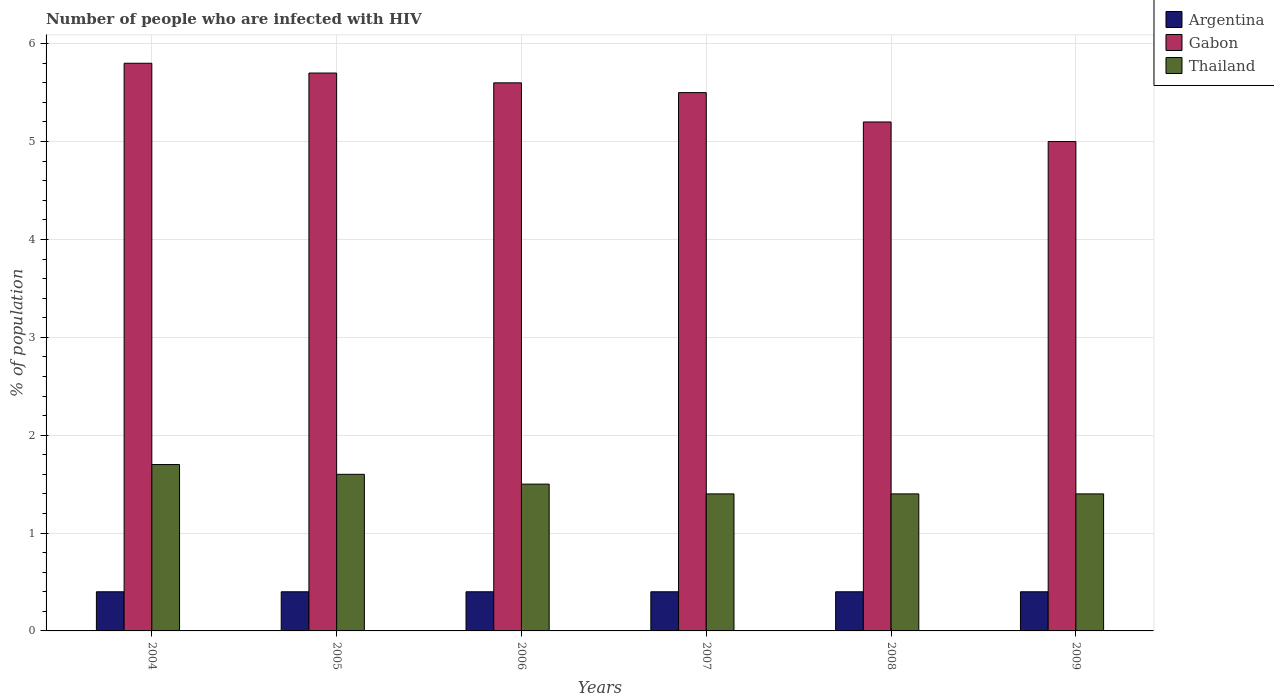How many different coloured bars are there?
Your answer should be very brief. 3. How many groups of bars are there?
Ensure brevity in your answer.  6. How many bars are there on the 6th tick from the right?
Provide a succinct answer. 3. What is the label of the 6th group of bars from the left?
Offer a very short reply. 2009. In how many cases, is the number of bars for a given year not equal to the number of legend labels?
Offer a very short reply. 0. Across all years, what is the maximum percentage of HIV infected population in in Thailand?
Your response must be concise. 1.7. What is the difference between the percentage of HIV infected population in in Thailand in 2005 and that in 2006?
Give a very brief answer. 0.1. What is the difference between the percentage of HIV infected population in in Thailand in 2008 and the percentage of HIV infected population in in Gabon in 2005?
Give a very brief answer. -4.3. What is the average percentage of HIV infected population in in Argentina per year?
Your answer should be compact. 0.4. In how many years, is the percentage of HIV infected population in in Argentina greater than 3.4 %?
Keep it short and to the point. 0. What is the ratio of the percentage of HIV infected population in in Gabon in 2004 to that in 2005?
Your answer should be compact. 1.02. Is the difference between the percentage of HIV infected population in in Argentina in 2007 and 2009 greater than the difference between the percentage of HIV infected population in in Gabon in 2007 and 2009?
Provide a short and direct response. No. What is the difference between the highest and the lowest percentage of HIV infected population in in Gabon?
Make the answer very short. 0.8. In how many years, is the percentage of HIV infected population in in Gabon greater than the average percentage of HIV infected population in in Gabon taken over all years?
Keep it short and to the point. 4. Is the sum of the percentage of HIV infected population in in Gabon in 2006 and 2009 greater than the maximum percentage of HIV infected population in in Thailand across all years?
Offer a very short reply. Yes. What does the 2nd bar from the left in 2007 represents?
Make the answer very short. Gabon. What does the 3rd bar from the right in 2007 represents?
Your answer should be compact. Argentina. How many bars are there?
Provide a short and direct response. 18. How many years are there in the graph?
Provide a short and direct response. 6. What is the difference between two consecutive major ticks on the Y-axis?
Keep it short and to the point. 1. Does the graph contain any zero values?
Keep it short and to the point. No. Where does the legend appear in the graph?
Give a very brief answer. Top right. What is the title of the graph?
Make the answer very short. Number of people who are infected with HIV. Does "Korea (Democratic)" appear as one of the legend labels in the graph?
Your response must be concise. No. What is the label or title of the X-axis?
Offer a terse response. Years. What is the label or title of the Y-axis?
Provide a succinct answer. % of population. What is the % of population in Thailand in 2004?
Provide a succinct answer. 1.7. What is the % of population of Thailand in 2005?
Your answer should be very brief. 1.6. What is the % of population in Argentina in 2006?
Your answer should be compact. 0.4. What is the % of population of Gabon in 2006?
Your response must be concise. 5.6. What is the % of population in Argentina in 2007?
Provide a short and direct response. 0.4. What is the % of population in Gabon in 2007?
Provide a short and direct response. 5.5. What is the % of population of Gabon in 2008?
Provide a succinct answer. 5.2. What is the % of population of Thailand in 2008?
Your answer should be very brief. 1.4. What is the % of population of Argentina in 2009?
Ensure brevity in your answer.  0.4. What is the % of population in Gabon in 2009?
Your answer should be very brief. 5. What is the % of population of Thailand in 2009?
Your response must be concise. 1.4. Across all years, what is the maximum % of population in Argentina?
Provide a succinct answer. 0.4. Across all years, what is the maximum % of population in Gabon?
Your answer should be compact. 5.8. Across all years, what is the minimum % of population in Argentina?
Your response must be concise. 0.4. Across all years, what is the minimum % of population in Thailand?
Provide a short and direct response. 1.4. What is the total % of population in Argentina in the graph?
Offer a terse response. 2.4. What is the total % of population of Gabon in the graph?
Your answer should be very brief. 32.8. What is the difference between the % of population in Gabon in 2004 and that in 2005?
Your answer should be compact. 0.1. What is the difference between the % of population of Thailand in 2004 and that in 2005?
Keep it short and to the point. 0.1. What is the difference between the % of population in Argentina in 2004 and that in 2006?
Give a very brief answer. 0. What is the difference between the % of population in Argentina in 2004 and that in 2007?
Your answer should be compact. 0. What is the difference between the % of population in Thailand in 2004 and that in 2007?
Your answer should be compact. 0.3. What is the difference between the % of population of Gabon in 2004 and that in 2008?
Provide a succinct answer. 0.6. What is the difference between the % of population in Thailand in 2004 and that in 2008?
Your answer should be very brief. 0.3. What is the difference between the % of population in Thailand in 2004 and that in 2009?
Make the answer very short. 0.3. What is the difference between the % of population of Argentina in 2005 and that in 2006?
Provide a succinct answer. 0. What is the difference between the % of population in Thailand in 2005 and that in 2007?
Offer a very short reply. 0.2. What is the difference between the % of population of Gabon in 2005 and that in 2009?
Make the answer very short. 0.7. What is the difference between the % of population of Thailand in 2006 and that in 2007?
Provide a short and direct response. 0.1. What is the difference between the % of population of Thailand in 2006 and that in 2008?
Ensure brevity in your answer.  0.1. What is the difference between the % of population in Gabon in 2006 and that in 2009?
Give a very brief answer. 0.6. What is the difference between the % of population in Thailand in 2006 and that in 2009?
Offer a very short reply. 0.1. What is the difference between the % of population of Gabon in 2007 and that in 2008?
Keep it short and to the point. 0.3. What is the difference between the % of population of Gabon in 2008 and that in 2009?
Offer a terse response. 0.2. What is the difference between the % of population of Argentina in 2004 and the % of population of Gabon in 2005?
Offer a very short reply. -5.3. What is the difference between the % of population in Gabon in 2004 and the % of population in Thailand in 2005?
Offer a terse response. 4.2. What is the difference between the % of population in Argentina in 2004 and the % of population in Thailand in 2006?
Keep it short and to the point. -1.1. What is the difference between the % of population of Gabon in 2004 and the % of population of Thailand in 2007?
Offer a very short reply. 4.4. What is the difference between the % of population in Gabon in 2004 and the % of population in Thailand in 2008?
Offer a terse response. 4.4. What is the difference between the % of population in Gabon in 2004 and the % of population in Thailand in 2009?
Give a very brief answer. 4.4. What is the difference between the % of population of Argentina in 2005 and the % of population of Gabon in 2006?
Offer a very short reply. -5.2. What is the difference between the % of population in Argentina in 2005 and the % of population in Thailand in 2007?
Give a very brief answer. -1. What is the difference between the % of population in Argentina in 2005 and the % of population in Thailand in 2009?
Ensure brevity in your answer.  -1. What is the difference between the % of population of Argentina in 2006 and the % of population of Thailand in 2007?
Offer a very short reply. -1. What is the difference between the % of population of Argentina in 2006 and the % of population of Thailand in 2008?
Give a very brief answer. -1. What is the difference between the % of population of Gabon in 2006 and the % of population of Thailand in 2008?
Offer a terse response. 4.2. What is the difference between the % of population of Argentina in 2006 and the % of population of Gabon in 2009?
Keep it short and to the point. -4.6. What is the difference between the % of population in Argentina in 2006 and the % of population in Thailand in 2009?
Your answer should be compact. -1. What is the difference between the % of population in Argentina in 2007 and the % of population in Gabon in 2008?
Make the answer very short. -4.8. What is the difference between the % of population in Argentina in 2007 and the % of population in Gabon in 2009?
Your answer should be very brief. -4.6. What is the difference between the % of population of Argentina in 2007 and the % of population of Thailand in 2009?
Make the answer very short. -1. What is the difference between the % of population of Gabon in 2007 and the % of population of Thailand in 2009?
Make the answer very short. 4.1. What is the difference between the % of population of Argentina in 2008 and the % of population of Gabon in 2009?
Your answer should be very brief. -4.6. What is the difference between the % of population of Gabon in 2008 and the % of population of Thailand in 2009?
Offer a very short reply. 3.8. What is the average % of population of Gabon per year?
Your answer should be very brief. 5.47. What is the average % of population of Thailand per year?
Keep it short and to the point. 1.5. In the year 2004, what is the difference between the % of population in Gabon and % of population in Thailand?
Keep it short and to the point. 4.1. In the year 2006, what is the difference between the % of population of Gabon and % of population of Thailand?
Ensure brevity in your answer.  4.1. In the year 2007, what is the difference between the % of population in Argentina and % of population in Gabon?
Your answer should be compact. -5.1. In the year 2008, what is the difference between the % of population of Argentina and % of population of Thailand?
Provide a short and direct response. -1. In the year 2009, what is the difference between the % of population of Argentina and % of population of Gabon?
Your answer should be very brief. -4.6. In the year 2009, what is the difference between the % of population in Gabon and % of population in Thailand?
Provide a short and direct response. 3.6. What is the ratio of the % of population of Gabon in 2004 to that in 2005?
Your answer should be compact. 1.02. What is the ratio of the % of population of Gabon in 2004 to that in 2006?
Offer a terse response. 1.04. What is the ratio of the % of population of Thailand in 2004 to that in 2006?
Your answer should be compact. 1.13. What is the ratio of the % of population in Gabon in 2004 to that in 2007?
Your answer should be compact. 1.05. What is the ratio of the % of population of Thailand in 2004 to that in 2007?
Your answer should be compact. 1.21. What is the ratio of the % of population in Argentina in 2004 to that in 2008?
Offer a very short reply. 1. What is the ratio of the % of population in Gabon in 2004 to that in 2008?
Offer a very short reply. 1.12. What is the ratio of the % of population in Thailand in 2004 to that in 2008?
Offer a terse response. 1.21. What is the ratio of the % of population of Gabon in 2004 to that in 2009?
Provide a succinct answer. 1.16. What is the ratio of the % of population in Thailand in 2004 to that in 2009?
Provide a succinct answer. 1.21. What is the ratio of the % of population of Gabon in 2005 to that in 2006?
Offer a very short reply. 1.02. What is the ratio of the % of population in Thailand in 2005 to that in 2006?
Your response must be concise. 1.07. What is the ratio of the % of population in Argentina in 2005 to that in 2007?
Provide a short and direct response. 1. What is the ratio of the % of population of Gabon in 2005 to that in 2007?
Provide a succinct answer. 1.04. What is the ratio of the % of population in Thailand in 2005 to that in 2007?
Provide a succinct answer. 1.14. What is the ratio of the % of population in Argentina in 2005 to that in 2008?
Make the answer very short. 1. What is the ratio of the % of population of Gabon in 2005 to that in 2008?
Your response must be concise. 1.1. What is the ratio of the % of population in Thailand in 2005 to that in 2008?
Give a very brief answer. 1.14. What is the ratio of the % of population of Argentina in 2005 to that in 2009?
Give a very brief answer. 1. What is the ratio of the % of population in Gabon in 2005 to that in 2009?
Offer a terse response. 1.14. What is the ratio of the % of population of Gabon in 2006 to that in 2007?
Make the answer very short. 1.02. What is the ratio of the % of population in Thailand in 2006 to that in 2007?
Your response must be concise. 1.07. What is the ratio of the % of population of Argentina in 2006 to that in 2008?
Give a very brief answer. 1. What is the ratio of the % of population in Thailand in 2006 to that in 2008?
Provide a short and direct response. 1.07. What is the ratio of the % of population in Argentina in 2006 to that in 2009?
Provide a short and direct response. 1. What is the ratio of the % of population of Gabon in 2006 to that in 2009?
Make the answer very short. 1.12. What is the ratio of the % of population in Thailand in 2006 to that in 2009?
Give a very brief answer. 1.07. What is the ratio of the % of population in Gabon in 2007 to that in 2008?
Your response must be concise. 1.06. What is the ratio of the % of population in Thailand in 2007 to that in 2008?
Your response must be concise. 1. What is the ratio of the % of population of Argentina in 2007 to that in 2009?
Offer a terse response. 1. What is the ratio of the % of population in Gabon in 2007 to that in 2009?
Offer a terse response. 1.1. What is the ratio of the % of population in Thailand in 2007 to that in 2009?
Offer a very short reply. 1. What is the ratio of the % of population in Argentina in 2008 to that in 2009?
Keep it short and to the point. 1. What is the ratio of the % of population of Gabon in 2008 to that in 2009?
Give a very brief answer. 1.04. What is the difference between the highest and the second highest % of population of Gabon?
Ensure brevity in your answer.  0.1. What is the difference between the highest and the lowest % of population in Argentina?
Your answer should be compact. 0. What is the difference between the highest and the lowest % of population of Thailand?
Keep it short and to the point. 0.3. 